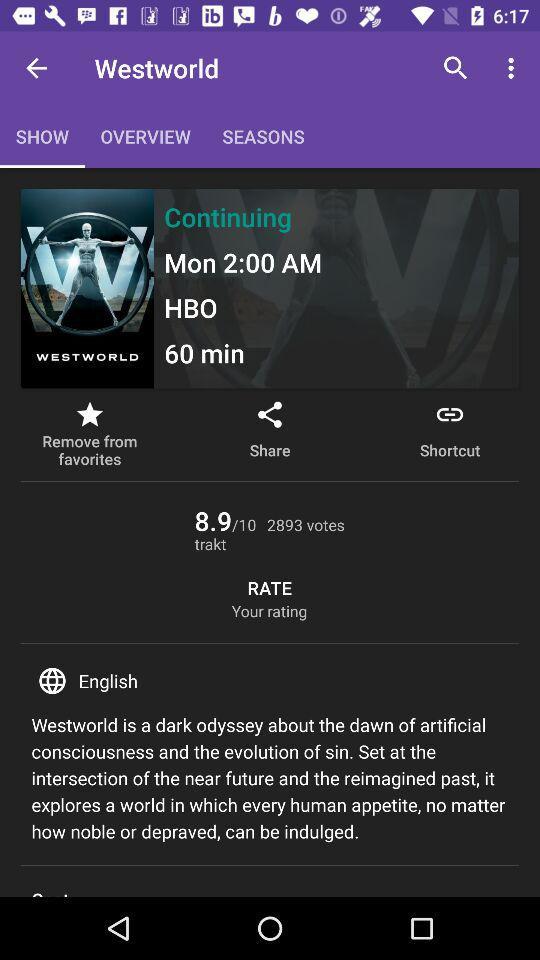What is the title of the show? The title of the show is "Westworld". 